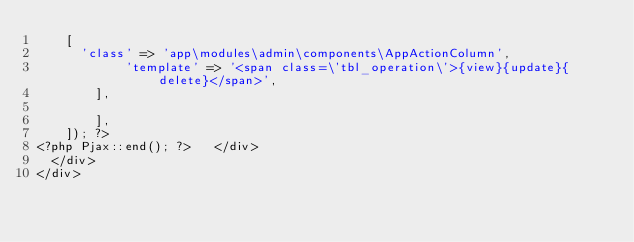Convert code to text. <code><loc_0><loc_0><loc_500><loc_500><_PHP_>		[
			'class' => 'app\modules\admin\components\AppActionColumn',
            'template' => '<span class=\'tbl_operation\'>{view}{update}{delete}</span>',
        ],
            
        ],
    ]); ?>
<?php Pjax::end(); ?>		</div>
	</div>
</div>

</code> 